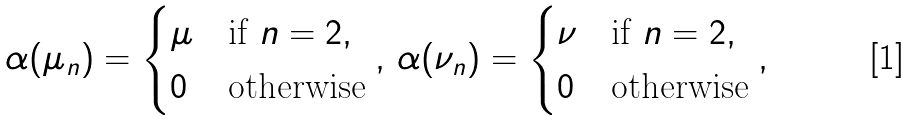Convert formula to latex. <formula><loc_0><loc_0><loc_500><loc_500>\alpha ( \mu _ { n } ) = \begin{cases} \mu & \text {if } n = 2 , \\ 0 & \text {otherwise} \end{cases} , \, \alpha ( \nu _ { n } ) = \begin{cases} \nu & \text {if } n = 2 , \\ 0 & \text {otherwise} \end{cases} ,</formula> 